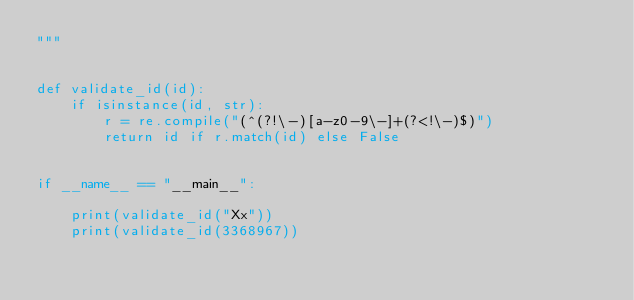<code> <loc_0><loc_0><loc_500><loc_500><_Python_>"""


def validate_id(id):
    if isinstance(id, str):
        r = re.compile("(^(?!\-)[a-z0-9\-]+(?<!\-)$)")
        return id if r.match(id) else False


if __name__ == "__main__":

    print(validate_id("Xx"))
    print(validate_id(3368967))
</code> 